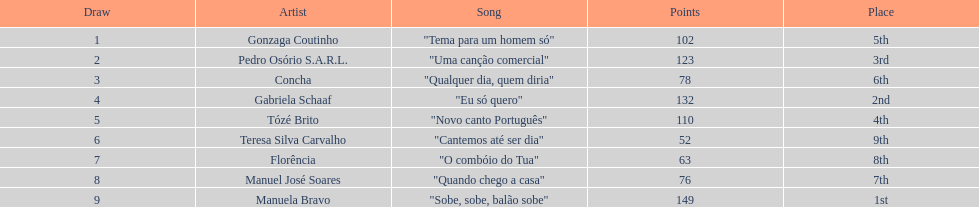I'm looking to parse the entire table for insights. Could you assist me with that? {'header': ['Draw', 'Artist', 'Song', 'Points', 'Place'], 'rows': [['1', 'Gonzaga Coutinho', '"Tema para um homem só"', '102', '5th'], ['2', 'Pedro Osório S.A.R.L.', '"Uma canção comercial"', '123', '3rd'], ['3', 'Concha', '"Qualquer dia, quem diria"', '78', '6th'], ['4', 'Gabriela Schaaf', '"Eu só quero"', '132', '2nd'], ['5', 'Tózé Brito', '"Novo canto Português"', '110', '4th'], ['6', 'Teresa Silva Carvalho', '"Cantemos até ser dia"', '52', '9th'], ['7', 'Florência', '"O combóio do Tua"', '63', '8th'], ['8', 'Manuel José Soares', '"Quando chego a casa"', '76', '7th'], ['9', 'Manuela Bravo', '"Sobe, sobe, balão sobe"', '149', '1st']]} Who scored the most points? Manuela Bravo. 